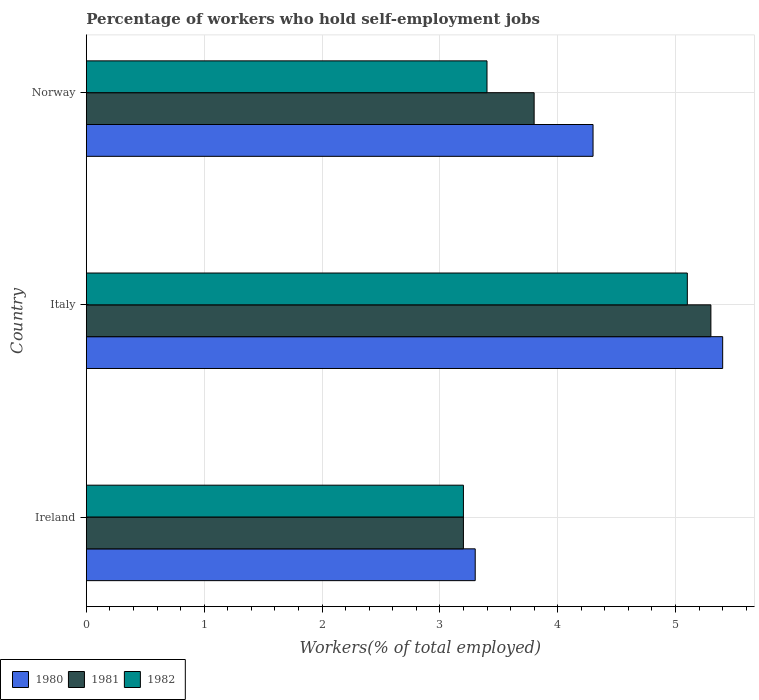How many different coloured bars are there?
Provide a short and direct response. 3. How many groups of bars are there?
Ensure brevity in your answer.  3. Are the number of bars per tick equal to the number of legend labels?
Offer a very short reply. Yes. Are the number of bars on each tick of the Y-axis equal?
Ensure brevity in your answer.  Yes. How many bars are there on the 1st tick from the bottom?
Provide a succinct answer. 3. What is the label of the 1st group of bars from the top?
Offer a very short reply. Norway. What is the percentage of self-employed workers in 1982 in Italy?
Provide a short and direct response. 5.1. Across all countries, what is the maximum percentage of self-employed workers in 1981?
Make the answer very short. 5.3. Across all countries, what is the minimum percentage of self-employed workers in 1980?
Offer a terse response. 3.3. In which country was the percentage of self-employed workers in 1980 minimum?
Give a very brief answer. Ireland. What is the total percentage of self-employed workers in 1980 in the graph?
Offer a very short reply. 13. What is the difference between the percentage of self-employed workers in 1980 in Ireland and that in Norway?
Provide a succinct answer. -1. What is the difference between the percentage of self-employed workers in 1982 in Italy and the percentage of self-employed workers in 1981 in Norway?
Provide a short and direct response. 1.3. What is the average percentage of self-employed workers in 1980 per country?
Provide a short and direct response. 4.33. What is the difference between the percentage of self-employed workers in 1980 and percentage of self-employed workers in 1982 in Italy?
Provide a short and direct response. 0.3. In how many countries, is the percentage of self-employed workers in 1981 greater than 1.4 %?
Your answer should be very brief. 3. What is the ratio of the percentage of self-employed workers in 1980 in Italy to that in Norway?
Offer a very short reply. 1.26. Is the percentage of self-employed workers in 1980 in Ireland less than that in Norway?
Your response must be concise. Yes. What is the difference between the highest and the second highest percentage of self-employed workers in 1981?
Provide a short and direct response. 1.5. What is the difference between the highest and the lowest percentage of self-employed workers in 1982?
Keep it short and to the point. 1.9. What does the 3rd bar from the bottom in Italy represents?
Provide a short and direct response. 1982. Is it the case that in every country, the sum of the percentage of self-employed workers in 1982 and percentage of self-employed workers in 1981 is greater than the percentage of self-employed workers in 1980?
Your answer should be compact. Yes. How many bars are there?
Give a very brief answer. 9. How many countries are there in the graph?
Your response must be concise. 3. What is the difference between two consecutive major ticks on the X-axis?
Offer a very short reply. 1. Are the values on the major ticks of X-axis written in scientific E-notation?
Make the answer very short. No. Does the graph contain grids?
Offer a very short reply. Yes. How many legend labels are there?
Provide a short and direct response. 3. How are the legend labels stacked?
Offer a very short reply. Horizontal. What is the title of the graph?
Your answer should be compact. Percentage of workers who hold self-employment jobs. What is the label or title of the X-axis?
Offer a terse response. Workers(% of total employed). What is the label or title of the Y-axis?
Your answer should be compact. Country. What is the Workers(% of total employed) in 1980 in Ireland?
Your response must be concise. 3.3. What is the Workers(% of total employed) of 1981 in Ireland?
Your answer should be very brief. 3.2. What is the Workers(% of total employed) of 1982 in Ireland?
Ensure brevity in your answer.  3.2. What is the Workers(% of total employed) of 1980 in Italy?
Offer a very short reply. 5.4. What is the Workers(% of total employed) of 1981 in Italy?
Your answer should be very brief. 5.3. What is the Workers(% of total employed) in 1982 in Italy?
Give a very brief answer. 5.1. What is the Workers(% of total employed) of 1980 in Norway?
Your answer should be compact. 4.3. What is the Workers(% of total employed) of 1981 in Norway?
Offer a terse response. 3.8. What is the Workers(% of total employed) in 1982 in Norway?
Ensure brevity in your answer.  3.4. Across all countries, what is the maximum Workers(% of total employed) in 1980?
Offer a terse response. 5.4. Across all countries, what is the maximum Workers(% of total employed) of 1981?
Give a very brief answer. 5.3. Across all countries, what is the maximum Workers(% of total employed) of 1982?
Provide a succinct answer. 5.1. Across all countries, what is the minimum Workers(% of total employed) in 1980?
Your response must be concise. 3.3. Across all countries, what is the minimum Workers(% of total employed) in 1981?
Provide a short and direct response. 3.2. Across all countries, what is the minimum Workers(% of total employed) in 1982?
Provide a succinct answer. 3.2. What is the total Workers(% of total employed) of 1980 in the graph?
Ensure brevity in your answer.  13. What is the total Workers(% of total employed) in 1982 in the graph?
Your response must be concise. 11.7. What is the difference between the Workers(% of total employed) of 1980 in Ireland and that in Norway?
Offer a very short reply. -1. What is the difference between the Workers(% of total employed) in 1981 in Ireland and that in Norway?
Make the answer very short. -0.6. What is the difference between the Workers(% of total employed) in 1982 in Ireland and that in Norway?
Provide a succinct answer. -0.2. What is the difference between the Workers(% of total employed) in 1980 in Italy and that in Norway?
Ensure brevity in your answer.  1.1. What is the difference between the Workers(% of total employed) in 1982 in Italy and that in Norway?
Make the answer very short. 1.7. What is the difference between the Workers(% of total employed) in 1980 in Ireland and the Workers(% of total employed) in 1982 in Italy?
Give a very brief answer. -1.8. What is the difference between the Workers(% of total employed) of 1980 in Italy and the Workers(% of total employed) of 1981 in Norway?
Your answer should be very brief. 1.6. What is the difference between the Workers(% of total employed) in 1981 in Italy and the Workers(% of total employed) in 1982 in Norway?
Your answer should be very brief. 1.9. What is the average Workers(% of total employed) in 1980 per country?
Keep it short and to the point. 4.33. What is the average Workers(% of total employed) in 1981 per country?
Make the answer very short. 4.1. What is the average Workers(% of total employed) in 1982 per country?
Keep it short and to the point. 3.9. What is the difference between the Workers(% of total employed) of 1980 and Workers(% of total employed) of 1981 in Ireland?
Provide a short and direct response. 0.1. What is the difference between the Workers(% of total employed) of 1980 and Workers(% of total employed) of 1982 in Ireland?
Ensure brevity in your answer.  0.1. What is the difference between the Workers(% of total employed) in 1980 and Workers(% of total employed) in 1981 in Norway?
Keep it short and to the point. 0.5. What is the ratio of the Workers(% of total employed) of 1980 in Ireland to that in Italy?
Your response must be concise. 0.61. What is the ratio of the Workers(% of total employed) in 1981 in Ireland to that in Italy?
Offer a very short reply. 0.6. What is the ratio of the Workers(% of total employed) of 1982 in Ireland to that in Italy?
Your answer should be compact. 0.63. What is the ratio of the Workers(% of total employed) of 1980 in Ireland to that in Norway?
Offer a terse response. 0.77. What is the ratio of the Workers(% of total employed) of 1981 in Ireland to that in Norway?
Ensure brevity in your answer.  0.84. What is the ratio of the Workers(% of total employed) of 1982 in Ireland to that in Norway?
Your answer should be compact. 0.94. What is the ratio of the Workers(% of total employed) of 1980 in Italy to that in Norway?
Your answer should be compact. 1.26. What is the ratio of the Workers(% of total employed) of 1981 in Italy to that in Norway?
Ensure brevity in your answer.  1.39. What is the ratio of the Workers(% of total employed) of 1982 in Italy to that in Norway?
Provide a succinct answer. 1.5. What is the difference between the highest and the second highest Workers(% of total employed) in 1980?
Offer a terse response. 1.1. What is the difference between the highest and the second highest Workers(% of total employed) of 1982?
Provide a short and direct response. 1.7. What is the difference between the highest and the lowest Workers(% of total employed) of 1981?
Offer a terse response. 2.1. What is the difference between the highest and the lowest Workers(% of total employed) of 1982?
Provide a short and direct response. 1.9. 